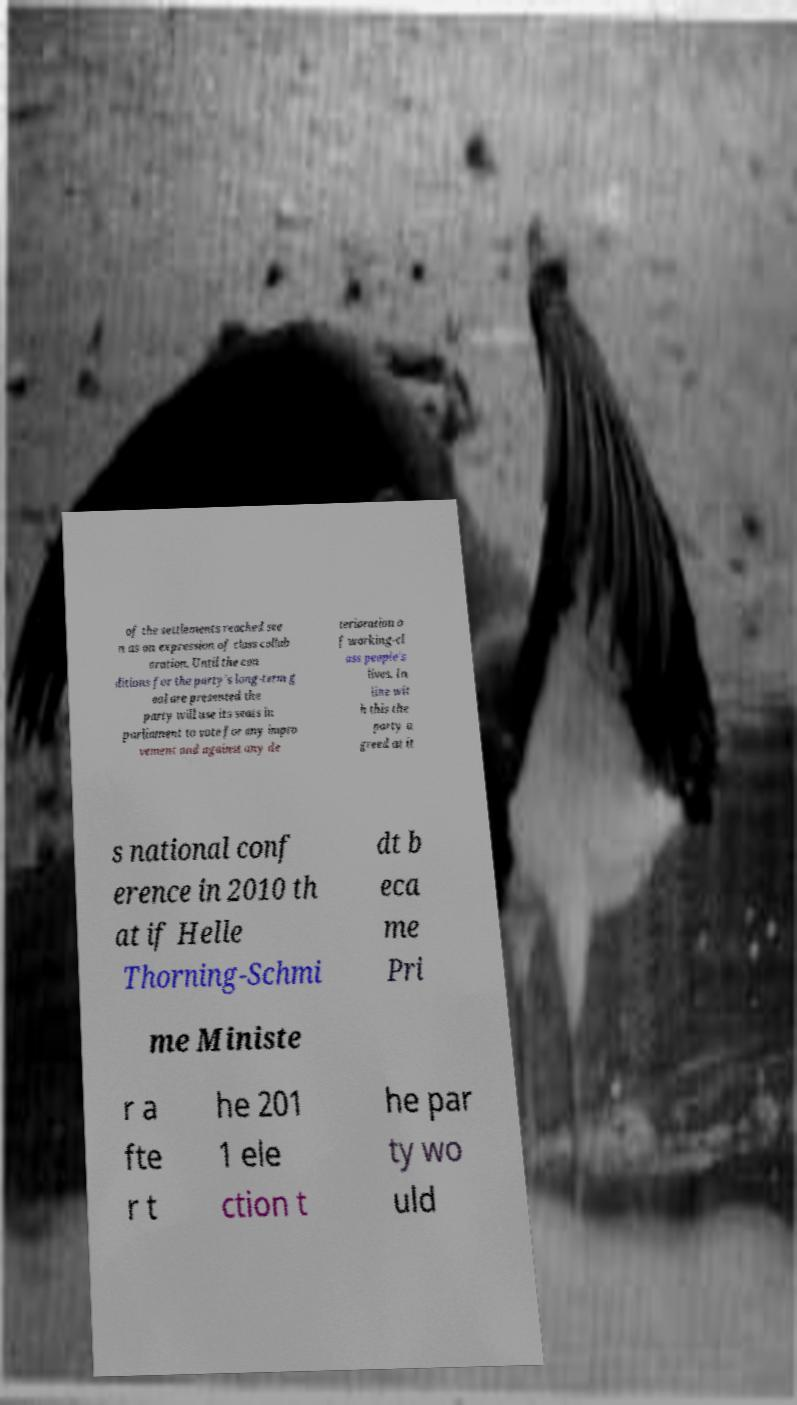Could you extract and type out the text from this image? of the settlements reached see n as an expression of class collab oration. Until the con ditions for the party's long-term g oal are presented the party will use its seats in parliament to vote for any impro vement and against any de terioration o f working-cl ass people's lives. In line wit h this the party a greed at it s national conf erence in 2010 th at if Helle Thorning-Schmi dt b eca me Pri me Ministe r a fte r t he 201 1 ele ction t he par ty wo uld 